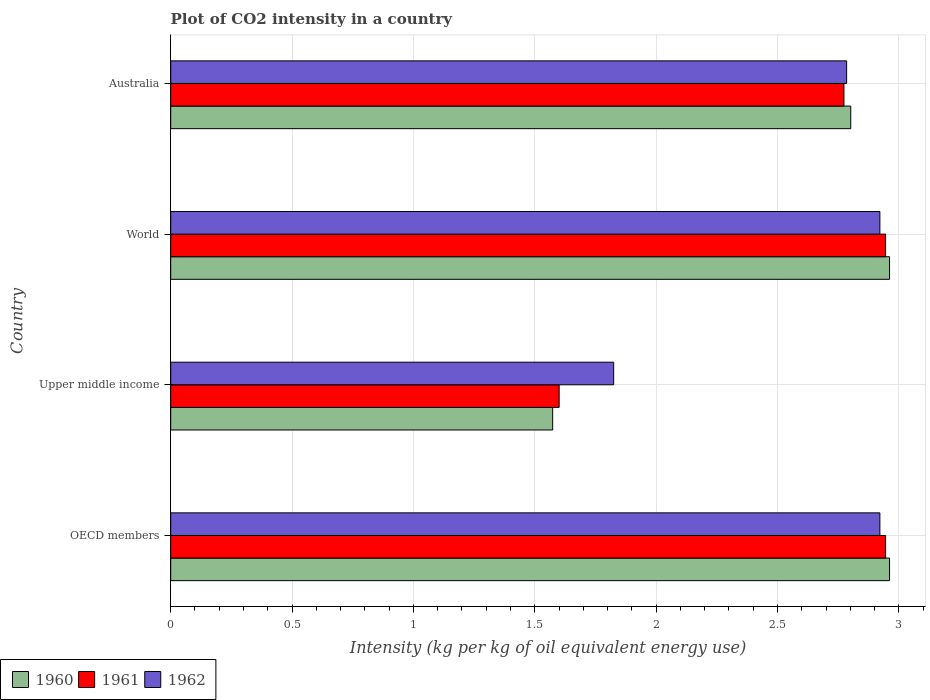How many groups of bars are there?
Make the answer very short. 4. Are the number of bars on each tick of the Y-axis equal?
Provide a short and direct response. Yes. How many bars are there on the 3rd tick from the top?
Your response must be concise. 3. How many bars are there on the 1st tick from the bottom?
Provide a succinct answer. 3. What is the label of the 3rd group of bars from the top?
Give a very brief answer. Upper middle income. What is the CO2 intensity in in 1962 in Australia?
Provide a succinct answer. 2.78. Across all countries, what is the maximum CO2 intensity in in 1960?
Make the answer very short. 2.96. Across all countries, what is the minimum CO2 intensity in in 1962?
Your answer should be very brief. 1.82. In which country was the CO2 intensity in in 1962 minimum?
Ensure brevity in your answer.  Upper middle income. What is the total CO2 intensity in in 1961 in the graph?
Your answer should be very brief. 10.26. What is the difference between the CO2 intensity in in 1962 in Australia and that in OECD members?
Provide a succinct answer. -0.14. What is the difference between the CO2 intensity in in 1962 in OECD members and the CO2 intensity in in 1960 in Australia?
Keep it short and to the point. 0.12. What is the average CO2 intensity in in 1961 per country?
Offer a terse response. 2.57. What is the difference between the CO2 intensity in in 1962 and CO2 intensity in in 1961 in World?
Ensure brevity in your answer.  -0.02. In how many countries, is the CO2 intensity in in 1960 greater than 0.4 kg?
Your response must be concise. 4. What is the ratio of the CO2 intensity in in 1961 in Australia to that in OECD members?
Keep it short and to the point. 0.94. Is the CO2 intensity in in 1962 in Australia less than that in World?
Offer a terse response. Yes. Is the difference between the CO2 intensity in in 1962 in OECD members and World greater than the difference between the CO2 intensity in in 1961 in OECD members and World?
Your answer should be very brief. No. What is the difference between the highest and the second highest CO2 intensity in in 1960?
Keep it short and to the point. 0. What is the difference between the highest and the lowest CO2 intensity in in 1961?
Provide a short and direct response. 1.34. Is the sum of the CO2 intensity in in 1962 in Upper middle income and World greater than the maximum CO2 intensity in in 1960 across all countries?
Provide a short and direct response. Yes. What does the 1st bar from the bottom in Upper middle income represents?
Your answer should be compact. 1960. Is it the case that in every country, the sum of the CO2 intensity in in 1962 and CO2 intensity in in 1960 is greater than the CO2 intensity in in 1961?
Make the answer very short. Yes. How many bars are there?
Your answer should be compact. 12. How many countries are there in the graph?
Your response must be concise. 4. Does the graph contain any zero values?
Provide a short and direct response. No. Where does the legend appear in the graph?
Provide a short and direct response. Bottom left. How many legend labels are there?
Offer a terse response. 3. What is the title of the graph?
Provide a succinct answer. Plot of CO2 intensity in a country. Does "1983" appear as one of the legend labels in the graph?
Give a very brief answer. No. What is the label or title of the X-axis?
Your answer should be compact. Intensity (kg per kg of oil equivalent energy use). What is the label or title of the Y-axis?
Your answer should be compact. Country. What is the Intensity (kg per kg of oil equivalent energy use) in 1960 in OECD members?
Make the answer very short. 2.96. What is the Intensity (kg per kg of oil equivalent energy use) in 1961 in OECD members?
Your answer should be compact. 2.95. What is the Intensity (kg per kg of oil equivalent energy use) in 1962 in OECD members?
Make the answer very short. 2.92. What is the Intensity (kg per kg of oil equivalent energy use) of 1960 in Upper middle income?
Give a very brief answer. 1.57. What is the Intensity (kg per kg of oil equivalent energy use) in 1961 in Upper middle income?
Ensure brevity in your answer.  1.6. What is the Intensity (kg per kg of oil equivalent energy use) in 1962 in Upper middle income?
Ensure brevity in your answer.  1.82. What is the Intensity (kg per kg of oil equivalent energy use) in 1960 in World?
Your response must be concise. 2.96. What is the Intensity (kg per kg of oil equivalent energy use) of 1961 in World?
Make the answer very short. 2.95. What is the Intensity (kg per kg of oil equivalent energy use) of 1962 in World?
Ensure brevity in your answer.  2.92. What is the Intensity (kg per kg of oil equivalent energy use) in 1960 in Australia?
Keep it short and to the point. 2.8. What is the Intensity (kg per kg of oil equivalent energy use) in 1961 in Australia?
Your answer should be very brief. 2.77. What is the Intensity (kg per kg of oil equivalent energy use) of 1962 in Australia?
Offer a terse response. 2.78. Across all countries, what is the maximum Intensity (kg per kg of oil equivalent energy use) in 1960?
Offer a very short reply. 2.96. Across all countries, what is the maximum Intensity (kg per kg of oil equivalent energy use) in 1961?
Your answer should be very brief. 2.95. Across all countries, what is the maximum Intensity (kg per kg of oil equivalent energy use) in 1962?
Give a very brief answer. 2.92. Across all countries, what is the minimum Intensity (kg per kg of oil equivalent energy use) of 1960?
Offer a terse response. 1.57. Across all countries, what is the minimum Intensity (kg per kg of oil equivalent energy use) of 1961?
Your response must be concise. 1.6. Across all countries, what is the minimum Intensity (kg per kg of oil equivalent energy use) of 1962?
Provide a short and direct response. 1.82. What is the total Intensity (kg per kg of oil equivalent energy use) of 1960 in the graph?
Your answer should be very brief. 10.3. What is the total Intensity (kg per kg of oil equivalent energy use) in 1961 in the graph?
Give a very brief answer. 10.26. What is the total Intensity (kg per kg of oil equivalent energy use) of 1962 in the graph?
Provide a short and direct response. 10.45. What is the difference between the Intensity (kg per kg of oil equivalent energy use) of 1960 in OECD members and that in Upper middle income?
Provide a short and direct response. 1.39. What is the difference between the Intensity (kg per kg of oil equivalent energy use) in 1961 in OECD members and that in Upper middle income?
Give a very brief answer. 1.34. What is the difference between the Intensity (kg per kg of oil equivalent energy use) of 1962 in OECD members and that in Upper middle income?
Give a very brief answer. 1.1. What is the difference between the Intensity (kg per kg of oil equivalent energy use) of 1961 in OECD members and that in World?
Keep it short and to the point. 0. What is the difference between the Intensity (kg per kg of oil equivalent energy use) in 1960 in OECD members and that in Australia?
Give a very brief answer. 0.16. What is the difference between the Intensity (kg per kg of oil equivalent energy use) in 1961 in OECD members and that in Australia?
Provide a short and direct response. 0.17. What is the difference between the Intensity (kg per kg of oil equivalent energy use) of 1962 in OECD members and that in Australia?
Ensure brevity in your answer.  0.14. What is the difference between the Intensity (kg per kg of oil equivalent energy use) in 1960 in Upper middle income and that in World?
Offer a very short reply. -1.39. What is the difference between the Intensity (kg per kg of oil equivalent energy use) of 1961 in Upper middle income and that in World?
Your answer should be very brief. -1.34. What is the difference between the Intensity (kg per kg of oil equivalent energy use) of 1962 in Upper middle income and that in World?
Offer a terse response. -1.1. What is the difference between the Intensity (kg per kg of oil equivalent energy use) of 1960 in Upper middle income and that in Australia?
Offer a very short reply. -1.23. What is the difference between the Intensity (kg per kg of oil equivalent energy use) in 1961 in Upper middle income and that in Australia?
Keep it short and to the point. -1.17. What is the difference between the Intensity (kg per kg of oil equivalent energy use) of 1962 in Upper middle income and that in Australia?
Your answer should be very brief. -0.96. What is the difference between the Intensity (kg per kg of oil equivalent energy use) in 1960 in World and that in Australia?
Provide a succinct answer. 0.16. What is the difference between the Intensity (kg per kg of oil equivalent energy use) in 1961 in World and that in Australia?
Provide a short and direct response. 0.17. What is the difference between the Intensity (kg per kg of oil equivalent energy use) of 1962 in World and that in Australia?
Offer a terse response. 0.14. What is the difference between the Intensity (kg per kg of oil equivalent energy use) of 1960 in OECD members and the Intensity (kg per kg of oil equivalent energy use) of 1961 in Upper middle income?
Provide a short and direct response. 1.36. What is the difference between the Intensity (kg per kg of oil equivalent energy use) of 1960 in OECD members and the Intensity (kg per kg of oil equivalent energy use) of 1962 in Upper middle income?
Your answer should be very brief. 1.14. What is the difference between the Intensity (kg per kg of oil equivalent energy use) of 1961 in OECD members and the Intensity (kg per kg of oil equivalent energy use) of 1962 in Upper middle income?
Offer a terse response. 1.12. What is the difference between the Intensity (kg per kg of oil equivalent energy use) in 1960 in OECD members and the Intensity (kg per kg of oil equivalent energy use) in 1961 in World?
Ensure brevity in your answer.  0.02. What is the difference between the Intensity (kg per kg of oil equivalent energy use) in 1960 in OECD members and the Intensity (kg per kg of oil equivalent energy use) in 1962 in World?
Ensure brevity in your answer.  0.04. What is the difference between the Intensity (kg per kg of oil equivalent energy use) in 1961 in OECD members and the Intensity (kg per kg of oil equivalent energy use) in 1962 in World?
Keep it short and to the point. 0.02. What is the difference between the Intensity (kg per kg of oil equivalent energy use) of 1960 in OECD members and the Intensity (kg per kg of oil equivalent energy use) of 1961 in Australia?
Your response must be concise. 0.19. What is the difference between the Intensity (kg per kg of oil equivalent energy use) of 1960 in OECD members and the Intensity (kg per kg of oil equivalent energy use) of 1962 in Australia?
Provide a succinct answer. 0.18. What is the difference between the Intensity (kg per kg of oil equivalent energy use) of 1961 in OECD members and the Intensity (kg per kg of oil equivalent energy use) of 1962 in Australia?
Your response must be concise. 0.16. What is the difference between the Intensity (kg per kg of oil equivalent energy use) in 1960 in Upper middle income and the Intensity (kg per kg of oil equivalent energy use) in 1961 in World?
Provide a short and direct response. -1.37. What is the difference between the Intensity (kg per kg of oil equivalent energy use) of 1960 in Upper middle income and the Intensity (kg per kg of oil equivalent energy use) of 1962 in World?
Your answer should be very brief. -1.35. What is the difference between the Intensity (kg per kg of oil equivalent energy use) of 1961 in Upper middle income and the Intensity (kg per kg of oil equivalent energy use) of 1962 in World?
Offer a very short reply. -1.32. What is the difference between the Intensity (kg per kg of oil equivalent energy use) in 1960 in Upper middle income and the Intensity (kg per kg of oil equivalent energy use) in 1962 in Australia?
Offer a very short reply. -1.21. What is the difference between the Intensity (kg per kg of oil equivalent energy use) in 1961 in Upper middle income and the Intensity (kg per kg of oil equivalent energy use) in 1962 in Australia?
Keep it short and to the point. -1.18. What is the difference between the Intensity (kg per kg of oil equivalent energy use) of 1960 in World and the Intensity (kg per kg of oil equivalent energy use) of 1961 in Australia?
Offer a very short reply. 0.19. What is the difference between the Intensity (kg per kg of oil equivalent energy use) in 1960 in World and the Intensity (kg per kg of oil equivalent energy use) in 1962 in Australia?
Offer a very short reply. 0.18. What is the difference between the Intensity (kg per kg of oil equivalent energy use) of 1961 in World and the Intensity (kg per kg of oil equivalent energy use) of 1962 in Australia?
Make the answer very short. 0.16. What is the average Intensity (kg per kg of oil equivalent energy use) in 1960 per country?
Offer a very short reply. 2.57. What is the average Intensity (kg per kg of oil equivalent energy use) of 1961 per country?
Ensure brevity in your answer.  2.57. What is the average Intensity (kg per kg of oil equivalent energy use) in 1962 per country?
Make the answer very short. 2.61. What is the difference between the Intensity (kg per kg of oil equivalent energy use) in 1960 and Intensity (kg per kg of oil equivalent energy use) in 1961 in OECD members?
Your answer should be very brief. 0.02. What is the difference between the Intensity (kg per kg of oil equivalent energy use) of 1960 and Intensity (kg per kg of oil equivalent energy use) of 1962 in OECD members?
Ensure brevity in your answer.  0.04. What is the difference between the Intensity (kg per kg of oil equivalent energy use) of 1961 and Intensity (kg per kg of oil equivalent energy use) of 1962 in OECD members?
Offer a terse response. 0.02. What is the difference between the Intensity (kg per kg of oil equivalent energy use) in 1960 and Intensity (kg per kg of oil equivalent energy use) in 1961 in Upper middle income?
Offer a terse response. -0.03. What is the difference between the Intensity (kg per kg of oil equivalent energy use) of 1960 and Intensity (kg per kg of oil equivalent energy use) of 1962 in Upper middle income?
Make the answer very short. -0.25. What is the difference between the Intensity (kg per kg of oil equivalent energy use) of 1961 and Intensity (kg per kg of oil equivalent energy use) of 1962 in Upper middle income?
Your answer should be very brief. -0.22. What is the difference between the Intensity (kg per kg of oil equivalent energy use) of 1960 and Intensity (kg per kg of oil equivalent energy use) of 1961 in World?
Provide a succinct answer. 0.02. What is the difference between the Intensity (kg per kg of oil equivalent energy use) in 1960 and Intensity (kg per kg of oil equivalent energy use) in 1962 in World?
Offer a terse response. 0.04. What is the difference between the Intensity (kg per kg of oil equivalent energy use) of 1961 and Intensity (kg per kg of oil equivalent energy use) of 1962 in World?
Your answer should be very brief. 0.02. What is the difference between the Intensity (kg per kg of oil equivalent energy use) in 1960 and Intensity (kg per kg of oil equivalent energy use) in 1961 in Australia?
Your answer should be very brief. 0.03. What is the difference between the Intensity (kg per kg of oil equivalent energy use) in 1960 and Intensity (kg per kg of oil equivalent energy use) in 1962 in Australia?
Provide a short and direct response. 0.02. What is the difference between the Intensity (kg per kg of oil equivalent energy use) of 1961 and Intensity (kg per kg of oil equivalent energy use) of 1962 in Australia?
Your response must be concise. -0.01. What is the ratio of the Intensity (kg per kg of oil equivalent energy use) of 1960 in OECD members to that in Upper middle income?
Give a very brief answer. 1.88. What is the ratio of the Intensity (kg per kg of oil equivalent energy use) of 1961 in OECD members to that in Upper middle income?
Give a very brief answer. 1.84. What is the ratio of the Intensity (kg per kg of oil equivalent energy use) in 1962 in OECD members to that in Upper middle income?
Keep it short and to the point. 1.6. What is the ratio of the Intensity (kg per kg of oil equivalent energy use) of 1960 in OECD members to that in World?
Keep it short and to the point. 1. What is the ratio of the Intensity (kg per kg of oil equivalent energy use) in 1961 in OECD members to that in World?
Provide a short and direct response. 1. What is the ratio of the Intensity (kg per kg of oil equivalent energy use) of 1962 in OECD members to that in World?
Keep it short and to the point. 1. What is the ratio of the Intensity (kg per kg of oil equivalent energy use) of 1960 in OECD members to that in Australia?
Offer a terse response. 1.06. What is the ratio of the Intensity (kg per kg of oil equivalent energy use) in 1961 in OECD members to that in Australia?
Your response must be concise. 1.06. What is the ratio of the Intensity (kg per kg of oil equivalent energy use) of 1962 in OECD members to that in Australia?
Your answer should be compact. 1.05. What is the ratio of the Intensity (kg per kg of oil equivalent energy use) of 1960 in Upper middle income to that in World?
Offer a very short reply. 0.53. What is the ratio of the Intensity (kg per kg of oil equivalent energy use) in 1961 in Upper middle income to that in World?
Provide a short and direct response. 0.54. What is the ratio of the Intensity (kg per kg of oil equivalent energy use) in 1962 in Upper middle income to that in World?
Make the answer very short. 0.62. What is the ratio of the Intensity (kg per kg of oil equivalent energy use) of 1960 in Upper middle income to that in Australia?
Ensure brevity in your answer.  0.56. What is the ratio of the Intensity (kg per kg of oil equivalent energy use) of 1961 in Upper middle income to that in Australia?
Provide a short and direct response. 0.58. What is the ratio of the Intensity (kg per kg of oil equivalent energy use) in 1962 in Upper middle income to that in Australia?
Provide a short and direct response. 0.66. What is the ratio of the Intensity (kg per kg of oil equivalent energy use) in 1960 in World to that in Australia?
Your response must be concise. 1.06. What is the ratio of the Intensity (kg per kg of oil equivalent energy use) of 1961 in World to that in Australia?
Offer a terse response. 1.06. What is the ratio of the Intensity (kg per kg of oil equivalent energy use) in 1962 in World to that in Australia?
Your response must be concise. 1.05. What is the difference between the highest and the second highest Intensity (kg per kg of oil equivalent energy use) of 1961?
Your answer should be compact. 0. What is the difference between the highest and the second highest Intensity (kg per kg of oil equivalent energy use) of 1962?
Ensure brevity in your answer.  0. What is the difference between the highest and the lowest Intensity (kg per kg of oil equivalent energy use) in 1960?
Make the answer very short. 1.39. What is the difference between the highest and the lowest Intensity (kg per kg of oil equivalent energy use) of 1961?
Ensure brevity in your answer.  1.34. What is the difference between the highest and the lowest Intensity (kg per kg of oil equivalent energy use) in 1962?
Give a very brief answer. 1.1. 